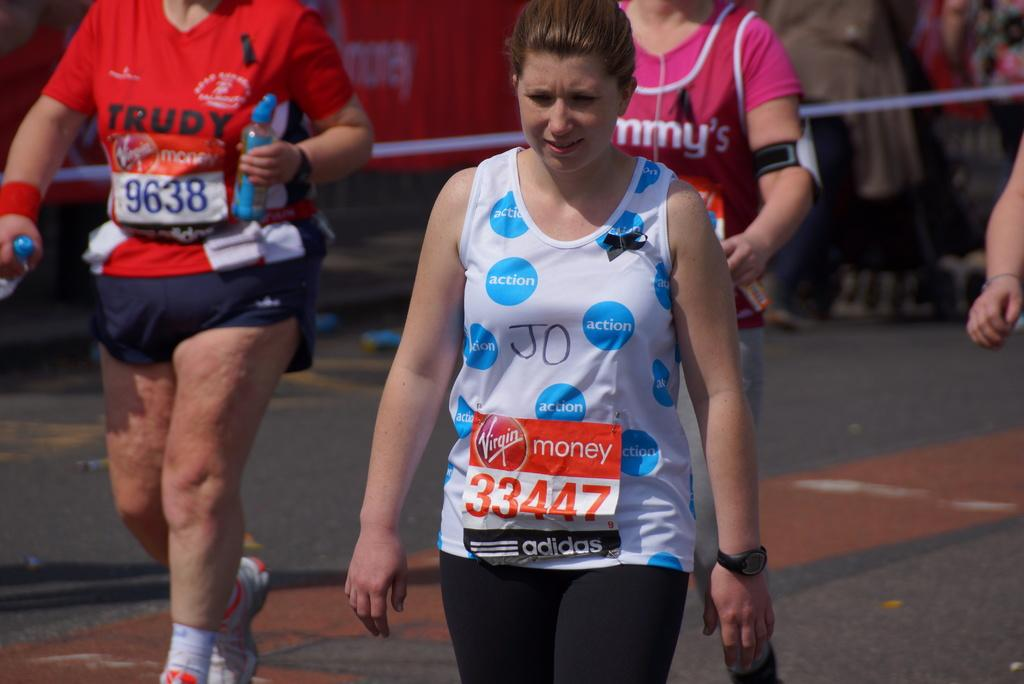<image>
Summarize the visual content of the image. Woman in a marathon with the word Action on her shirt. 